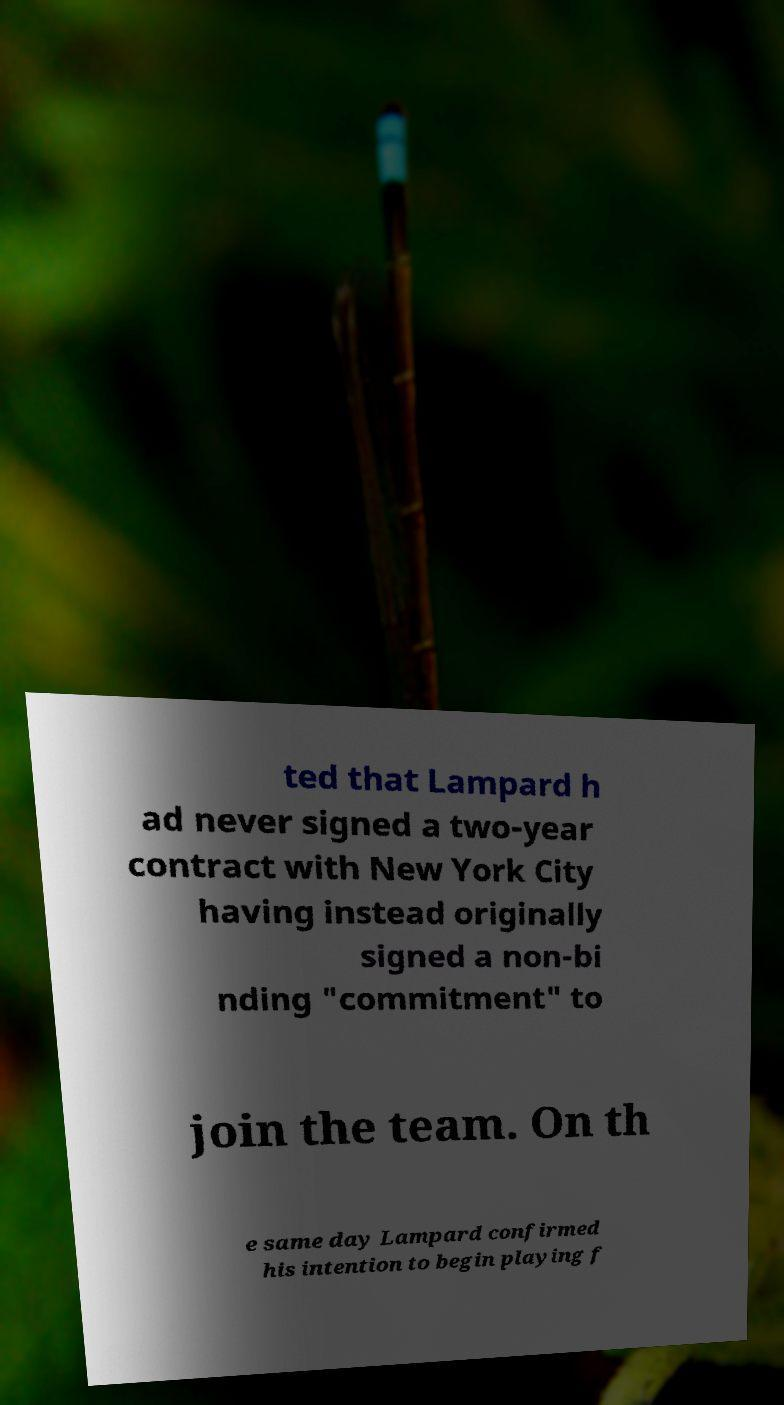Please identify and transcribe the text found in this image. ted that Lampard h ad never signed a two-year contract with New York City having instead originally signed a non-bi nding "commitment" to join the team. On th e same day Lampard confirmed his intention to begin playing f 